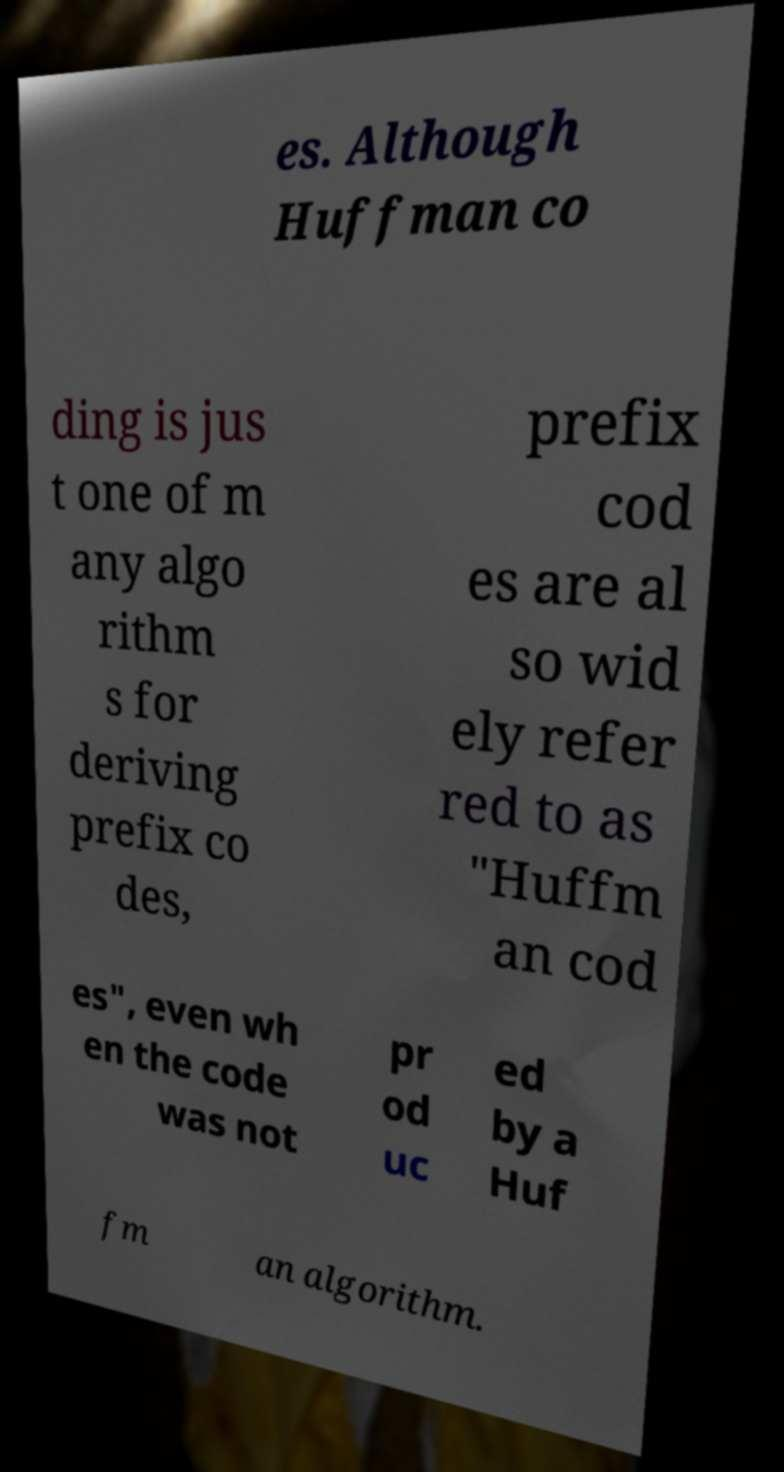What messages or text are displayed in this image? I need them in a readable, typed format. es. Although Huffman co ding is jus t one of m any algo rithm s for deriving prefix co des, prefix cod es are al so wid ely refer red to as "Huffm an cod es", even wh en the code was not pr od uc ed by a Huf fm an algorithm. 